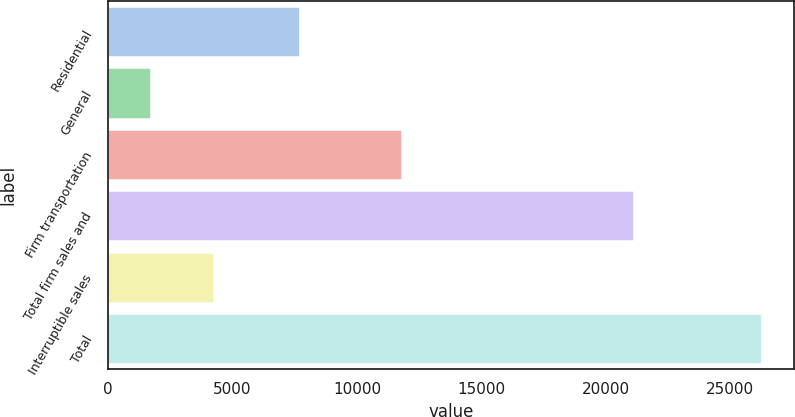<chart> <loc_0><loc_0><loc_500><loc_500><bar_chart><fcel>Residential<fcel>General<fcel>Firm transportation<fcel>Total firm sales and<fcel>Interruptible sales<fcel>Total<nl><fcel>7664<fcel>1684<fcel>11752<fcel>21100<fcel>4205<fcel>26236<nl></chart> 